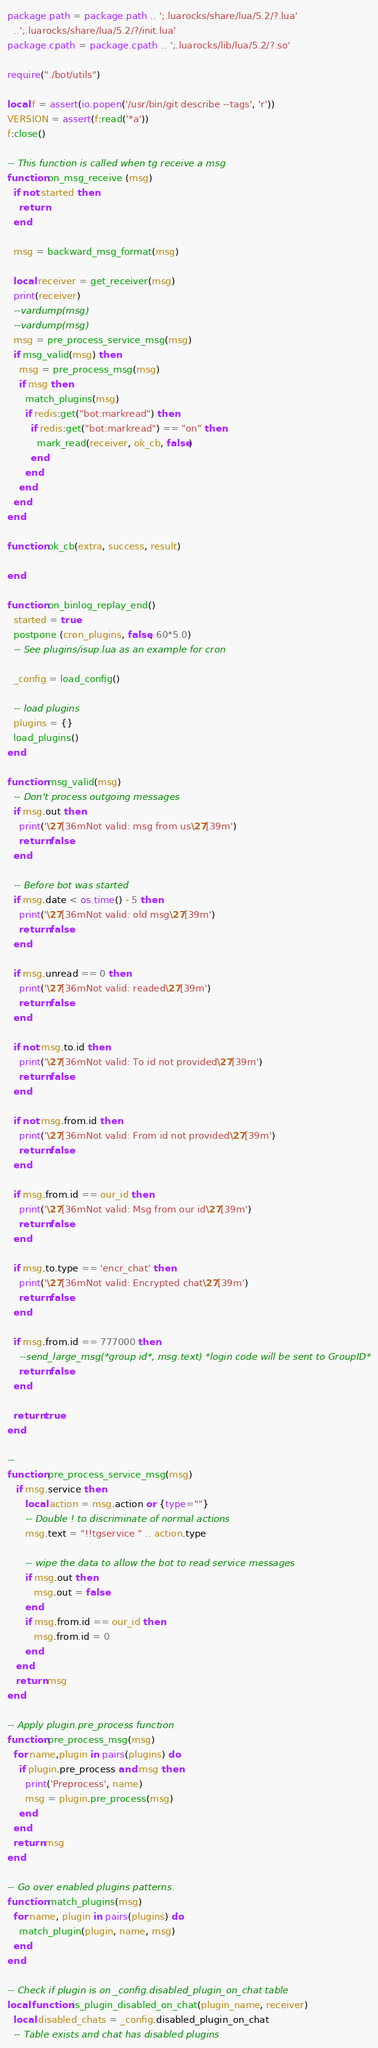<code> <loc_0><loc_0><loc_500><loc_500><_Lua_>package.path = package.path .. ';.luarocks/share/lua/5.2/?.lua'
  ..';.luarocks/share/lua/5.2/?/init.lua'
package.cpath = package.cpath .. ';.luarocks/lib/lua/5.2/?.so'

require("./bot/utils")

local f = assert(io.popen('/usr/bin/git describe --tags', 'r'))
VERSION = assert(f:read('*a'))
f:close()

-- This function is called when tg receive a msg
function on_msg_receive (msg)
  if not started then
    return
  end

  msg = backward_msg_format(msg)

  local receiver = get_receiver(msg)
  print(receiver)
  --vardump(msg)
  --vardump(msg)
  msg = pre_process_service_msg(msg)
  if msg_valid(msg) then
    msg = pre_process_msg(msg)
    if msg then
      match_plugins(msg)
      if redis:get("bot:markread") then
        if redis:get("bot:markread") == "on" then
          mark_read(receiver, ok_cb, false)
        end
      end
    end
  end
end

function ok_cb(extra, success, result)

end

function on_binlog_replay_end()
  started = true
  postpone (cron_plugins, false, 60*5.0)
  -- See plugins/isup.lua as an example for cron

  _config = load_config()

  -- load plugins
  plugins = {}
  load_plugins()
end

function msg_valid(msg)
  -- Don't process outgoing messages
  if msg.out then
    print('\27[36mNot valid: msg from us\27[39m')
    return false
  end

  -- Before bot was started
  if msg.date < os.time() - 5 then
    print('\27[36mNot valid: old msg\27[39m')
    return false
  end

  if msg.unread == 0 then
    print('\27[36mNot valid: readed\27[39m')
    return false
  end

  if not msg.to.id then
    print('\27[36mNot valid: To id not provided\27[39m')
    return false
  end

  if not msg.from.id then
    print('\27[36mNot valid: From id not provided\27[39m')
    return false
  end

  if msg.from.id == our_id then
    print('\27[36mNot valid: Msg from our id\27[39m')
    return false
  end

  if msg.to.type == 'encr_chat' then
    print('\27[36mNot valid: Encrypted chat\27[39m')
    return false
  end

  if msg.from.id == 777000 then
    --send_large_msg(*group id*, msg.text) *login code will be sent to GroupID*
    return false
  end

  return true
end

--
function pre_process_service_msg(msg)
   if msg.service then
      local action = msg.action or {type=""}
      -- Double ! to discriminate of normal actions
      msg.text = "!!tgservice " .. action.type

      -- wipe the data to allow the bot to read service messages
      if msg.out then
         msg.out = false
      end
      if msg.from.id == our_id then
         msg.from.id = 0
      end
   end
   return msg
end

-- Apply plugin.pre_process function
function pre_process_msg(msg)
  for name,plugin in pairs(plugins) do
    if plugin.pre_process and msg then
      print('Preprocess', name)
      msg = plugin.pre_process(msg)
    end
  end
  return msg
end

-- Go over enabled plugins patterns.
function match_plugins(msg)
  for name, plugin in pairs(plugins) do
    match_plugin(plugin, name, msg)
  end
end

-- Check if plugin is on _config.disabled_plugin_on_chat table
local function is_plugin_disabled_on_chat(plugin_name, receiver)
  local disabled_chats = _config.disabled_plugin_on_chat
  -- Table exists and chat has disabled plugins</code> 